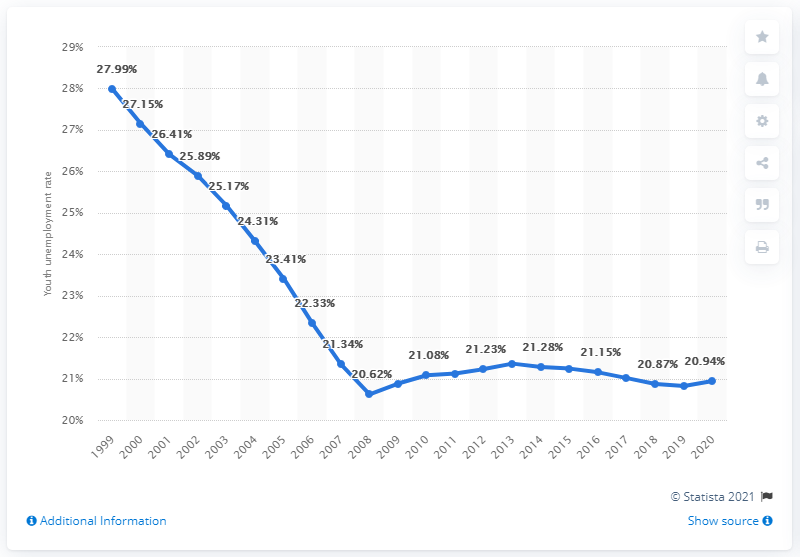Specify some key components in this picture. The youth unemployment rate in Tajikistan in 2020 was 20.94%. 